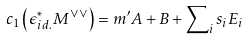Convert formula to latex. <formula><loc_0><loc_0><loc_500><loc_500>c _ { 1 } \left ( \epsilon _ { i d . } ^ { * } M ^ { \vee \vee } \right ) = m ^ { \prime } A + B + \sum \nolimits _ { i } s _ { i } E _ { i }</formula> 